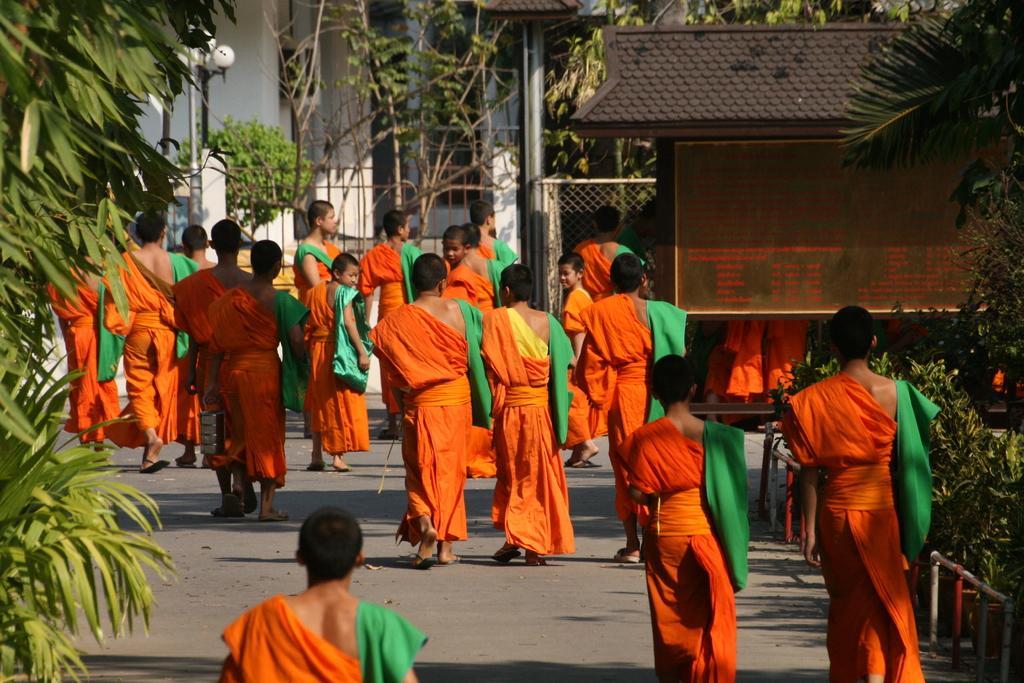Please provide a concise description of this image. This image is taken outdoors. At the bottom of the image there is a road. On the left side of the image there is a tree. In the middle of the image a few people are walking on the road. In the background there are few trees and plants and there is a house. There is a street light. On the right side of the image there is a hut, a mesh and there are a few trees and plants. 